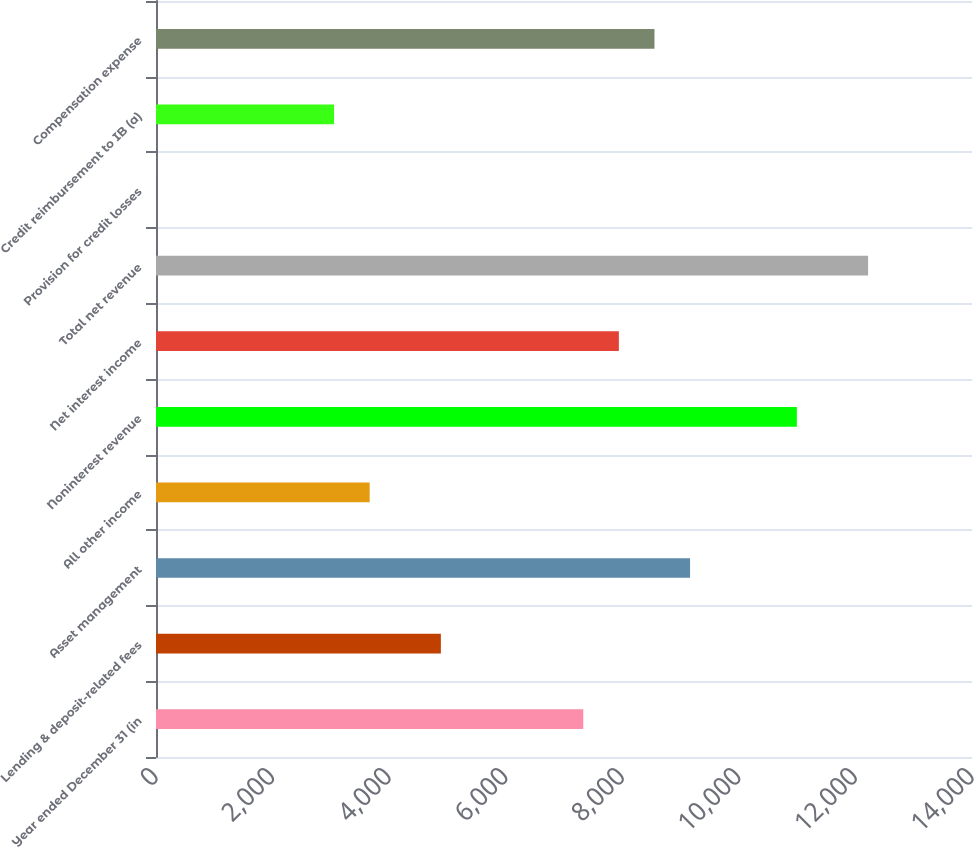Convert chart to OTSL. <chart><loc_0><loc_0><loc_500><loc_500><bar_chart><fcel>Year ended December 31 (in<fcel>Lending & deposit-related fees<fcel>Asset management<fcel>All other income<fcel>Noninterest revenue<fcel>Net interest income<fcel>Total net revenue<fcel>Provision for credit losses<fcel>Credit reimbursement to IB (a)<fcel>Compensation expense<nl><fcel>7330.6<fcel>4887.4<fcel>9163<fcel>3665.8<fcel>10995.4<fcel>7941.4<fcel>12217<fcel>1<fcel>3055<fcel>8552.2<nl></chart> 